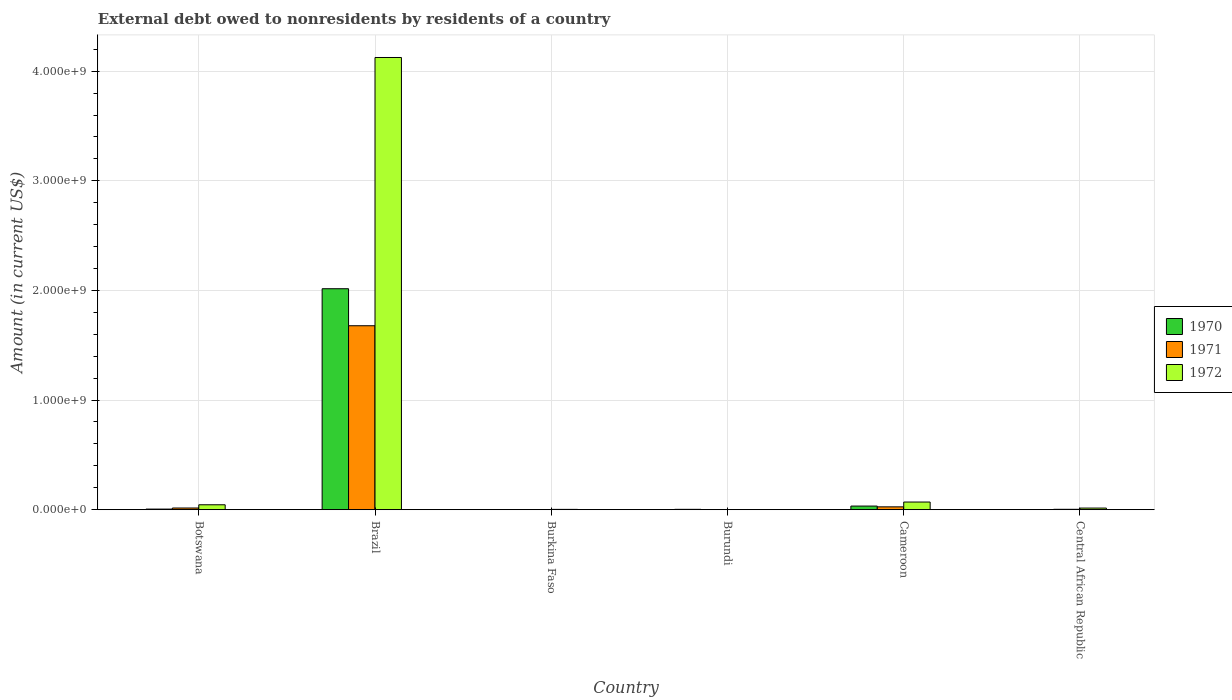Are the number of bars per tick equal to the number of legend labels?
Provide a short and direct response. No. How many bars are there on the 2nd tick from the left?
Provide a succinct answer. 3. How many bars are there on the 3rd tick from the right?
Make the answer very short. 1. What is the label of the 6th group of bars from the left?
Offer a very short reply. Central African Republic. In how many cases, is the number of bars for a given country not equal to the number of legend labels?
Offer a terse response. 2. What is the external debt owed by residents in 1972 in Botswana?
Offer a terse response. 4.50e+07. Across all countries, what is the maximum external debt owed by residents in 1971?
Your response must be concise. 1.68e+09. Across all countries, what is the minimum external debt owed by residents in 1971?
Your answer should be compact. 0. In which country was the external debt owed by residents in 1970 maximum?
Your answer should be very brief. Brazil. What is the total external debt owed by residents in 1972 in the graph?
Ensure brevity in your answer.  4.26e+09. What is the difference between the external debt owed by residents in 1970 in Botswana and that in Cameroon?
Give a very brief answer. -2.75e+07. What is the difference between the external debt owed by residents in 1971 in Brazil and the external debt owed by residents in 1970 in Central African Republic?
Provide a short and direct response. 1.68e+09. What is the average external debt owed by residents in 1971 per country?
Provide a short and direct response. 2.87e+08. What is the difference between the external debt owed by residents of/in 1972 and external debt owed by residents of/in 1971 in Central African Republic?
Your response must be concise. 1.11e+07. What is the ratio of the external debt owed by residents in 1970 in Burkina Faso to that in Burundi?
Ensure brevity in your answer.  0.2. Is the external debt owed by residents in 1970 in Brazil less than that in Cameroon?
Your answer should be compact. No. Is the difference between the external debt owed by residents in 1972 in Brazil and Cameroon greater than the difference between the external debt owed by residents in 1971 in Brazil and Cameroon?
Your answer should be compact. Yes. What is the difference between the highest and the second highest external debt owed by residents in 1971?
Your answer should be compact. 1.66e+09. What is the difference between the highest and the lowest external debt owed by residents in 1972?
Give a very brief answer. 4.13e+09. In how many countries, is the external debt owed by residents in 1971 greater than the average external debt owed by residents in 1971 taken over all countries?
Give a very brief answer. 1. Is it the case that in every country, the sum of the external debt owed by residents in 1971 and external debt owed by residents in 1970 is greater than the external debt owed by residents in 1972?
Ensure brevity in your answer.  No. How many bars are there?
Offer a very short reply. 15. What is the difference between two consecutive major ticks on the Y-axis?
Your answer should be very brief. 1.00e+09. Are the values on the major ticks of Y-axis written in scientific E-notation?
Offer a very short reply. Yes. Does the graph contain any zero values?
Your answer should be very brief. Yes. Does the graph contain grids?
Provide a succinct answer. Yes. How are the legend labels stacked?
Give a very brief answer. Vertical. What is the title of the graph?
Ensure brevity in your answer.  External debt owed to nonresidents by residents of a country. Does "1991" appear as one of the legend labels in the graph?
Provide a succinct answer. No. What is the label or title of the Y-axis?
Your answer should be very brief. Amount (in current US$). What is the Amount (in current US$) in 1970 in Botswana?
Offer a very short reply. 5.57e+06. What is the Amount (in current US$) in 1971 in Botswana?
Provide a short and direct response. 1.54e+07. What is the Amount (in current US$) of 1972 in Botswana?
Provide a short and direct response. 4.50e+07. What is the Amount (in current US$) of 1970 in Brazil?
Offer a very short reply. 2.02e+09. What is the Amount (in current US$) in 1971 in Brazil?
Offer a very short reply. 1.68e+09. What is the Amount (in current US$) of 1972 in Brazil?
Offer a terse response. 4.13e+09. What is the Amount (in current US$) of 1970 in Burkina Faso?
Provide a short and direct response. 6.51e+05. What is the Amount (in current US$) in 1971 in Burkina Faso?
Give a very brief answer. 1.32e+06. What is the Amount (in current US$) of 1972 in Burkina Faso?
Provide a short and direct response. 2.91e+06. What is the Amount (in current US$) in 1970 in Burundi?
Your response must be concise. 3.25e+06. What is the Amount (in current US$) of 1970 in Cameroon?
Keep it short and to the point. 3.30e+07. What is the Amount (in current US$) of 1971 in Cameroon?
Offer a terse response. 2.60e+07. What is the Amount (in current US$) of 1972 in Cameroon?
Offer a terse response. 6.98e+07. What is the Amount (in current US$) in 1970 in Central African Republic?
Give a very brief answer. 0. What is the Amount (in current US$) in 1971 in Central African Republic?
Give a very brief answer. 3.64e+06. What is the Amount (in current US$) of 1972 in Central African Republic?
Offer a very short reply. 1.48e+07. Across all countries, what is the maximum Amount (in current US$) of 1970?
Provide a succinct answer. 2.02e+09. Across all countries, what is the maximum Amount (in current US$) of 1971?
Your answer should be very brief. 1.68e+09. Across all countries, what is the maximum Amount (in current US$) in 1972?
Provide a succinct answer. 4.13e+09. Across all countries, what is the minimum Amount (in current US$) of 1970?
Your answer should be very brief. 0. Across all countries, what is the minimum Amount (in current US$) of 1971?
Your answer should be very brief. 0. What is the total Amount (in current US$) of 1970 in the graph?
Give a very brief answer. 2.06e+09. What is the total Amount (in current US$) of 1971 in the graph?
Keep it short and to the point. 1.72e+09. What is the total Amount (in current US$) of 1972 in the graph?
Make the answer very short. 4.26e+09. What is the difference between the Amount (in current US$) of 1970 in Botswana and that in Brazil?
Keep it short and to the point. -2.01e+09. What is the difference between the Amount (in current US$) in 1971 in Botswana and that in Brazil?
Your answer should be very brief. -1.66e+09. What is the difference between the Amount (in current US$) in 1972 in Botswana and that in Brazil?
Give a very brief answer. -4.08e+09. What is the difference between the Amount (in current US$) of 1970 in Botswana and that in Burkina Faso?
Offer a terse response. 4.92e+06. What is the difference between the Amount (in current US$) of 1971 in Botswana and that in Burkina Faso?
Offer a terse response. 1.41e+07. What is the difference between the Amount (in current US$) of 1972 in Botswana and that in Burkina Faso?
Give a very brief answer. 4.20e+07. What is the difference between the Amount (in current US$) of 1970 in Botswana and that in Burundi?
Your answer should be compact. 2.32e+06. What is the difference between the Amount (in current US$) of 1970 in Botswana and that in Cameroon?
Make the answer very short. -2.75e+07. What is the difference between the Amount (in current US$) in 1971 in Botswana and that in Cameroon?
Make the answer very short. -1.06e+07. What is the difference between the Amount (in current US$) of 1972 in Botswana and that in Cameroon?
Keep it short and to the point. -2.49e+07. What is the difference between the Amount (in current US$) of 1971 in Botswana and that in Central African Republic?
Make the answer very short. 1.17e+07. What is the difference between the Amount (in current US$) of 1972 in Botswana and that in Central African Republic?
Keep it short and to the point. 3.02e+07. What is the difference between the Amount (in current US$) in 1970 in Brazil and that in Burkina Faso?
Your answer should be very brief. 2.02e+09. What is the difference between the Amount (in current US$) of 1971 in Brazil and that in Burkina Faso?
Ensure brevity in your answer.  1.68e+09. What is the difference between the Amount (in current US$) of 1972 in Brazil and that in Burkina Faso?
Your answer should be compact. 4.12e+09. What is the difference between the Amount (in current US$) in 1970 in Brazil and that in Burundi?
Give a very brief answer. 2.01e+09. What is the difference between the Amount (in current US$) in 1970 in Brazil and that in Cameroon?
Your answer should be very brief. 1.98e+09. What is the difference between the Amount (in current US$) of 1971 in Brazil and that in Cameroon?
Provide a short and direct response. 1.65e+09. What is the difference between the Amount (in current US$) of 1972 in Brazil and that in Cameroon?
Ensure brevity in your answer.  4.06e+09. What is the difference between the Amount (in current US$) of 1971 in Brazil and that in Central African Republic?
Your answer should be very brief. 1.67e+09. What is the difference between the Amount (in current US$) in 1972 in Brazil and that in Central African Republic?
Provide a succinct answer. 4.11e+09. What is the difference between the Amount (in current US$) of 1970 in Burkina Faso and that in Burundi?
Ensure brevity in your answer.  -2.60e+06. What is the difference between the Amount (in current US$) of 1970 in Burkina Faso and that in Cameroon?
Your answer should be compact. -3.24e+07. What is the difference between the Amount (in current US$) of 1971 in Burkina Faso and that in Cameroon?
Make the answer very short. -2.47e+07. What is the difference between the Amount (in current US$) of 1972 in Burkina Faso and that in Cameroon?
Give a very brief answer. -6.69e+07. What is the difference between the Amount (in current US$) of 1971 in Burkina Faso and that in Central African Republic?
Make the answer very short. -2.32e+06. What is the difference between the Amount (in current US$) in 1972 in Burkina Faso and that in Central African Republic?
Your answer should be compact. -1.19e+07. What is the difference between the Amount (in current US$) in 1970 in Burundi and that in Cameroon?
Provide a short and direct response. -2.98e+07. What is the difference between the Amount (in current US$) of 1971 in Cameroon and that in Central African Republic?
Offer a very short reply. 2.23e+07. What is the difference between the Amount (in current US$) in 1972 in Cameroon and that in Central African Republic?
Your answer should be very brief. 5.50e+07. What is the difference between the Amount (in current US$) in 1970 in Botswana and the Amount (in current US$) in 1971 in Brazil?
Ensure brevity in your answer.  -1.67e+09. What is the difference between the Amount (in current US$) in 1970 in Botswana and the Amount (in current US$) in 1972 in Brazil?
Provide a succinct answer. -4.12e+09. What is the difference between the Amount (in current US$) of 1971 in Botswana and the Amount (in current US$) of 1972 in Brazil?
Offer a terse response. -4.11e+09. What is the difference between the Amount (in current US$) of 1970 in Botswana and the Amount (in current US$) of 1971 in Burkina Faso?
Ensure brevity in your answer.  4.25e+06. What is the difference between the Amount (in current US$) in 1970 in Botswana and the Amount (in current US$) in 1972 in Burkina Faso?
Make the answer very short. 2.66e+06. What is the difference between the Amount (in current US$) of 1971 in Botswana and the Amount (in current US$) of 1972 in Burkina Faso?
Offer a very short reply. 1.25e+07. What is the difference between the Amount (in current US$) in 1970 in Botswana and the Amount (in current US$) in 1971 in Cameroon?
Your answer should be very brief. -2.04e+07. What is the difference between the Amount (in current US$) in 1970 in Botswana and the Amount (in current US$) in 1972 in Cameroon?
Your answer should be very brief. -6.42e+07. What is the difference between the Amount (in current US$) in 1971 in Botswana and the Amount (in current US$) in 1972 in Cameroon?
Your response must be concise. -5.44e+07. What is the difference between the Amount (in current US$) of 1970 in Botswana and the Amount (in current US$) of 1971 in Central African Republic?
Provide a succinct answer. 1.92e+06. What is the difference between the Amount (in current US$) in 1970 in Botswana and the Amount (in current US$) in 1972 in Central African Republic?
Give a very brief answer. -9.21e+06. What is the difference between the Amount (in current US$) in 1971 in Botswana and the Amount (in current US$) in 1972 in Central African Republic?
Provide a succinct answer. 6.07e+05. What is the difference between the Amount (in current US$) in 1970 in Brazil and the Amount (in current US$) in 1971 in Burkina Faso?
Your answer should be compact. 2.01e+09. What is the difference between the Amount (in current US$) in 1970 in Brazil and the Amount (in current US$) in 1972 in Burkina Faso?
Your answer should be compact. 2.01e+09. What is the difference between the Amount (in current US$) in 1971 in Brazil and the Amount (in current US$) in 1972 in Burkina Faso?
Your response must be concise. 1.68e+09. What is the difference between the Amount (in current US$) in 1970 in Brazil and the Amount (in current US$) in 1971 in Cameroon?
Provide a succinct answer. 1.99e+09. What is the difference between the Amount (in current US$) of 1970 in Brazil and the Amount (in current US$) of 1972 in Cameroon?
Your response must be concise. 1.95e+09. What is the difference between the Amount (in current US$) of 1971 in Brazil and the Amount (in current US$) of 1972 in Cameroon?
Provide a succinct answer. 1.61e+09. What is the difference between the Amount (in current US$) in 1970 in Brazil and the Amount (in current US$) in 1971 in Central African Republic?
Keep it short and to the point. 2.01e+09. What is the difference between the Amount (in current US$) of 1970 in Brazil and the Amount (in current US$) of 1972 in Central African Republic?
Make the answer very short. 2.00e+09. What is the difference between the Amount (in current US$) of 1971 in Brazil and the Amount (in current US$) of 1972 in Central African Republic?
Offer a very short reply. 1.66e+09. What is the difference between the Amount (in current US$) in 1970 in Burkina Faso and the Amount (in current US$) in 1971 in Cameroon?
Keep it short and to the point. -2.53e+07. What is the difference between the Amount (in current US$) in 1970 in Burkina Faso and the Amount (in current US$) in 1972 in Cameroon?
Make the answer very short. -6.92e+07. What is the difference between the Amount (in current US$) of 1971 in Burkina Faso and the Amount (in current US$) of 1972 in Cameroon?
Ensure brevity in your answer.  -6.85e+07. What is the difference between the Amount (in current US$) in 1970 in Burkina Faso and the Amount (in current US$) in 1971 in Central African Republic?
Provide a short and direct response. -2.99e+06. What is the difference between the Amount (in current US$) of 1970 in Burkina Faso and the Amount (in current US$) of 1972 in Central African Republic?
Make the answer very short. -1.41e+07. What is the difference between the Amount (in current US$) of 1971 in Burkina Faso and the Amount (in current US$) of 1972 in Central African Republic?
Offer a terse response. -1.35e+07. What is the difference between the Amount (in current US$) of 1970 in Burundi and the Amount (in current US$) of 1971 in Cameroon?
Make the answer very short. -2.27e+07. What is the difference between the Amount (in current US$) of 1970 in Burundi and the Amount (in current US$) of 1972 in Cameroon?
Provide a succinct answer. -6.66e+07. What is the difference between the Amount (in current US$) of 1970 in Burundi and the Amount (in current US$) of 1971 in Central African Republic?
Your answer should be compact. -3.96e+05. What is the difference between the Amount (in current US$) of 1970 in Burundi and the Amount (in current US$) of 1972 in Central African Republic?
Give a very brief answer. -1.15e+07. What is the difference between the Amount (in current US$) in 1970 in Cameroon and the Amount (in current US$) in 1971 in Central African Republic?
Provide a succinct answer. 2.94e+07. What is the difference between the Amount (in current US$) of 1970 in Cameroon and the Amount (in current US$) of 1972 in Central African Republic?
Your answer should be compact. 1.83e+07. What is the difference between the Amount (in current US$) in 1971 in Cameroon and the Amount (in current US$) in 1972 in Central African Republic?
Give a very brief answer. 1.12e+07. What is the average Amount (in current US$) in 1970 per country?
Provide a succinct answer. 3.43e+08. What is the average Amount (in current US$) in 1971 per country?
Make the answer very short. 2.87e+08. What is the average Amount (in current US$) in 1972 per country?
Make the answer very short. 7.10e+08. What is the difference between the Amount (in current US$) of 1970 and Amount (in current US$) of 1971 in Botswana?
Your answer should be very brief. -9.82e+06. What is the difference between the Amount (in current US$) of 1970 and Amount (in current US$) of 1972 in Botswana?
Your response must be concise. -3.94e+07. What is the difference between the Amount (in current US$) of 1971 and Amount (in current US$) of 1972 in Botswana?
Provide a succinct answer. -2.96e+07. What is the difference between the Amount (in current US$) of 1970 and Amount (in current US$) of 1971 in Brazil?
Give a very brief answer. 3.38e+08. What is the difference between the Amount (in current US$) of 1970 and Amount (in current US$) of 1972 in Brazil?
Make the answer very short. -2.11e+09. What is the difference between the Amount (in current US$) in 1971 and Amount (in current US$) in 1972 in Brazil?
Offer a very short reply. -2.45e+09. What is the difference between the Amount (in current US$) of 1970 and Amount (in current US$) of 1971 in Burkina Faso?
Your answer should be compact. -6.68e+05. What is the difference between the Amount (in current US$) of 1970 and Amount (in current US$) of 1972 in Burkina Faso?
Your answer should be very brief. -2.26e+06. What is the difference between the Amount (in current US$) in 1971 and Amount (in current US$) in 1972 in Burkina Faso?
Keep it short and to the point. -1.59e+06. What is the difference between the Amount (in current US$) in 1970 and Amount (in current US$) in 1971 in Cameroon?
Offer a very short reply. 7.06e+06. What is the difference between the Amount (in current US$) in 1970 and Amount (in current US$) in 1972 in Cameroon?
Provide a succinct answer. -3.68e+07. What is the difference between the Amount (in current US$) of 1971 and Amount (in current US$) of 1972 in Cameroon?
Your answer should be compact. -4.38e+07. What is the difference between the Amount (in current US$) of 1971 and Amount (in current US$) of 1972 in Central African Republic?
Keep it short and to the point. -1.11e+07. What is the ratio of the Amount (in current US$) in 1970 in Botswana to that in Brazil?
Give a very brief answer. 0. What is the ratio of the Amount (in current US$) in 1971 in Botswana to that in Brazil?
Ensure brevity in your answer.  0.01. What is the ratio of the Amount (in current US$) of 1972 in Botswana to that in Brazil?
Your answer should be very brief. 0.01. What is the ratio of the Amount (in current US$) in 1970 in Botswana to that in Burkina Faso?
Ensure brevity in your answer.  8.55. What is the ratio of the Amount (in current US$) in 1971 in Botswana to that in Burkina Faso?
Make the answer very short. 11.67. What is the ratio of the Amount (in current US$) of 1972 in Botswana to that in Burkina Faso?
Provide a succinct answer. 15.47. What is the ratio of the Amount (in current US$) of 1970 in Botswana to that in Burundi?
Your response must be concise. 1.71. What is the ratio of the Amount (in current US$) in 1970 in Botswana to that in Cameroon?
Your answer should be compact. 0.17. What is the ratio of the Amount (in current US$) of 1971 in Botswana to that in Cameroon?
Give a very brief answer. 0.59. What is the ratio of the Amount (in current US$) in 1972 in Botswana to that in Cameroon?
Provide a succinct answer. 0.64. What is the ratio of the Amount (in current US$) in 1971 in Botswana to that in Central African Republic?
Provide a short and direct response. 4.22. What is the ratio of the Amount (in current US$) in 1972 in Botswana to that in Central African Republic?
Your answer should be very brief. 3.04. What is the ratio of the Amount (in current US$) in 1970 in Brazil to that in Burkina Faso?
Your response must be concise. 3096.3. What is the ratio of the Amount (in current US$) of 1971 in Brazil to that in Burkina Faso?
Provide a short and direct response. 1272.21. What is the ratio of the Amount (in current US$) in 1972 in Brazil to that in Burkina Faso?
Your answer should be compact. 1419.49. What is the ratio of the Amount (in current US$) of 1970 in Brazil to that in Burundi?
Your answer should be very brief. 620.79. What is the ratio of the Amount (in current US$) of 1970 in Brazil to that in Cameroon?
Offer a very short reply. 61.02. What is the ratio of the Amount (in current US$) of 1971 in Brazil to that in Cameroon?
Your response must be concise. 64.6. What is the ratio of the Amount (in current US$) of 1972 in Brazil to that in Cameroon?
Your answer should be very brief. 59.09. What is the ratio of the Amount (in current US$) in 1971 in Brazil to that in Central African Republic?
Make the answer very short. 460.62. What is the ratio of the Amount (in current US$) of 1972 in Brazil to that in Central African Republic?
Offer a terse response. 279.1. What is the ratio of the Amount (in current US$) in 1970 in Burkina Faso to that in Burundi?
Make the answer very short. 0.2. What is the ratio of the Amount (in current US$) in 1970 in Burkina Faso to that in Cameroon?
Provide a short and direct response. 0.02. What is the ratio of the Amount (in current US$) of 1971 in Burkina Faso to that in Cameroon?
Make the answer very short. 0.05. What is the ratio of the Amount (in current US$) in 1972 in Burkina Faso to that in Cameroon?
Keep it short and to the point. 0.04. What is the ratio of the Amount (in current US$) in 1971 in Burkina Faso to that in Central African Republic?
Make the answer very short. 0.36. What is the ratio of the Amount (in current US$) of 1972 in Burkina Faso to that in Central African Republic?
Your response must be concise. 0.2. What is the ratio of the Amount (in current US$) of 1970 in Burundi to that in Cameroon?
Provide a succinct answer. 0.1. What is the ratio of the Amount (in current US$) in 1971 in Cameroon to that in Central African Republic?
Offer a very short reply. 7.13. What is the ratio of the Amount (in current US$) of 1972 in Cameroon to that in Central African Republic?
Provide a short and direct response. 4.72. What is the difference between the highest and the second highest Amount (in current US$) in 1970?
Give a very brief answer. 1.98e+09. What is the difference between the highest and the second highest Amount (in current US$) of 1971?
Your answer should be compact. 1.65e+09. What is the difference between the highest and the second highest Amount (in current US$) of 1972?
Ensure brevity in your answer.  4.06e+09. What is the difference between the highest and the lowest Amount (in current US$) of 1970?
Make the answer very short. 2.02e+09. What is the difference between the highest and the lowest Amount (in current US$) of 1971?
Provide a short and direct response. 1.68e+09. What is the difference between the highest and the lowest Amount (in current US$) in 1972?
Offer a very short reply. 4.13e+09. 